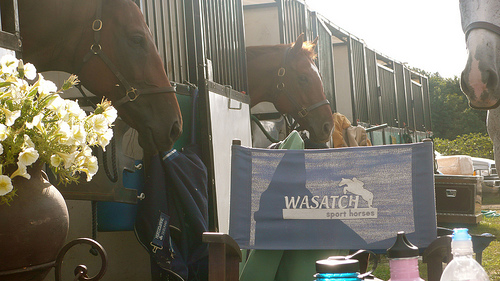<image>
Can you confirm if the horse is to the left of the banner? No. The horse is not to the left of the banner. From this viewpoint, they have a different horizontal relationship. 